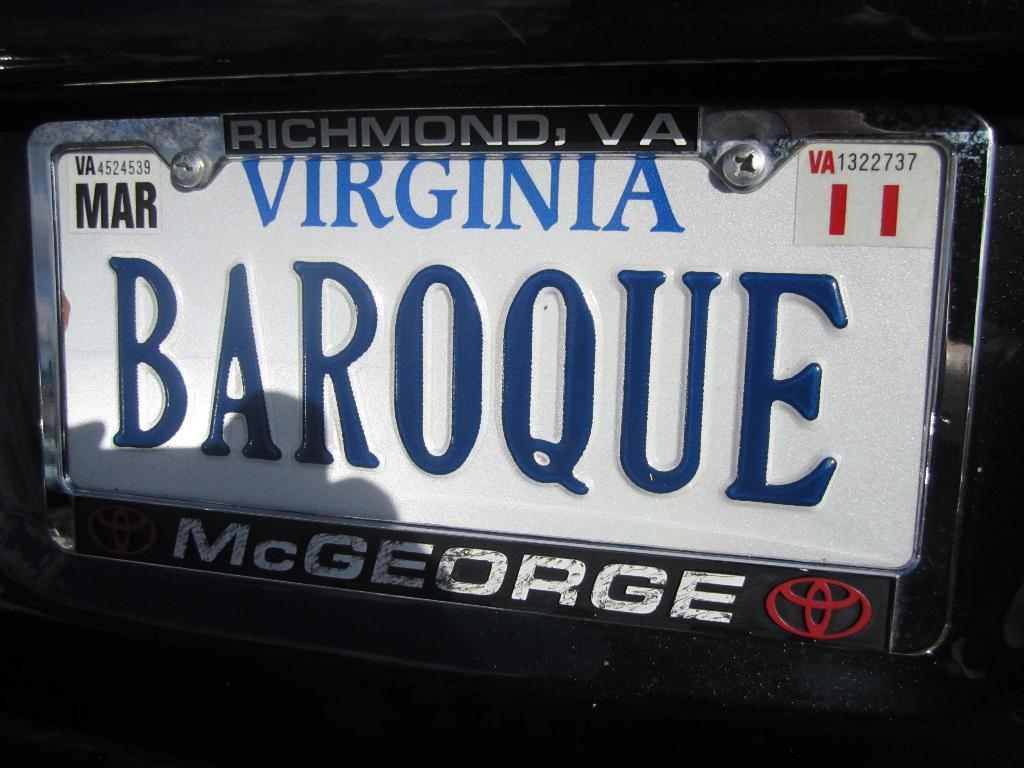<image>
Summarize the visual content of the image. A custom Virginia license plate with the word "baroque" in all caps. 